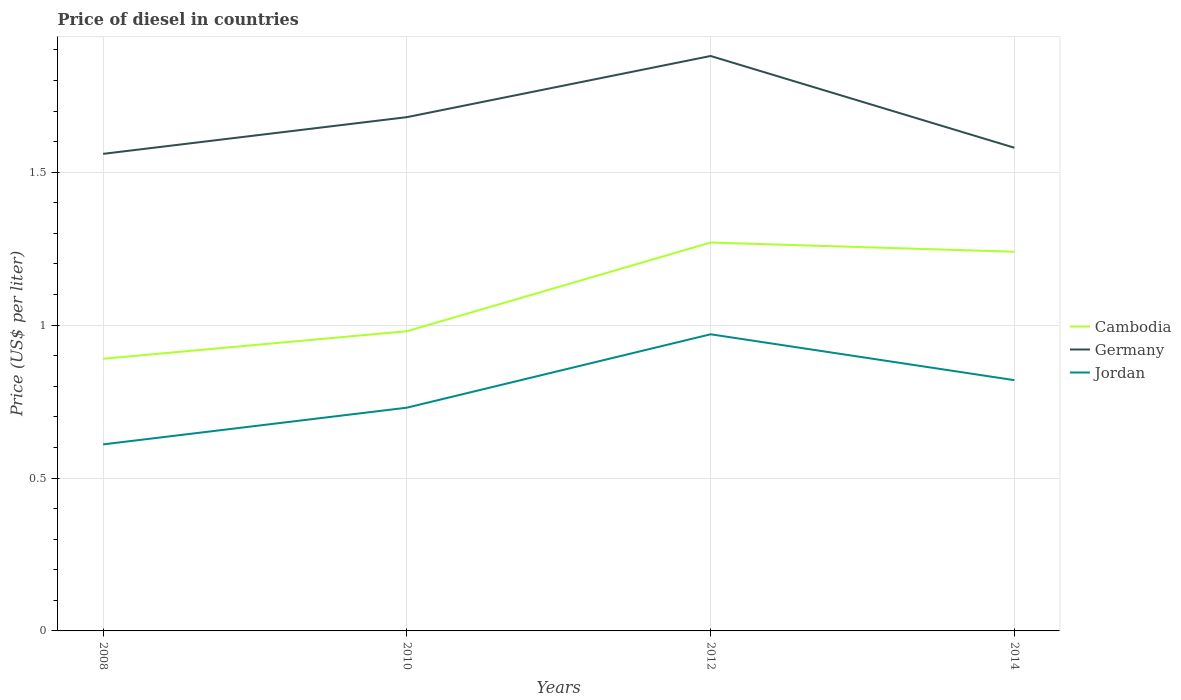Across all years, what is the maximum price of diesel in Germany?
Provide a succinct answer. 1.56. In which year was the price of diesel in Germany maximum?
Make the answer very short. 2008. What is the total price of diesel in Germany in the graph?
Offer a very short reply. -0.02. What is the difference between the highest and the second highest price of diesel in Germany?
Provide a short and direct response. 0.32. What is the difference between two consecutive major ticks on the Y-axis?
Offer a terse response. 0.5. Are the values on the major ticks of Y-axis written in scientific E-notation?
Your answer should be compact. No. What is the title of the graph?
Provide a succinct answer. Price of diesel in countries. What is the label or title of the Y-axis?
Your response must be concise. Price (US$ per liter). What is the Price (US$ per liter) of Cambodia in 2008?
Keep it short and to the point. 0.89. What is the Price (US$ per liter) in Germany in 2008?
Provide a short and direct response. 1.56. What is the Price (US$ per liter) of Jordan in 2008?
Ensure brevity in your answer.  0.61. What is the Price (US$ per liter) in Cambodia in 2010?
Offer a terse response. 0.98. What is the Price (US$ per liter) of Germany in 2010?
Give a very brief answer. 1.68. What is the Price (US$ per liter) of Jordan in 2010?
Your response must be concise. 0.73. What is the Price (US$ per liter) of Cambodia in 2012?
Your answer should be very brief. 1.27. What is the Price (US$ per liter) in Germany in 2012?
Your response must be concise. 1.88. What is the Price (US$ per liter) in Cambodia in 2014?
Make the answer very short. 1.24. What is the Price (US$ per liter) in Germany in 2014?
Provide a succinct answer. 1.58. What is the Price (US$ per liter) of Jordan in 2014?
Offer a terse response. 0.82. Across all years, what is the maximum Price (US$ per liter) of Cambodia?
Provide a succinct answer. 1.27. Across all years, what is the maximum Price (US$ per liter) in Germany?
Keep it short and to the point. 1.88. Across all years, what is the minimum Price (US$ per liter) in Cambodia?
Your response must be concise. 0.89. Across all years, what is the minimum Price (US$ per liter) of Germany?
Give a very brief answer. 1.56. Across all years, what is the minimum Price (US$ per liter) of Jordan?
Make the answer very short. 0.61. What is the total Price (US$ per liter) in Cambodia in the graph?
Keep it short and to the point. 4.38. What is the total Price (US$ per liter) in Jordan in the graph?
Your response must be concise. 3.13. What is the difference between the Price (US$ per liter) of Cambodia in 2008 and that in 2010?
Ensure brevity in your answer.  -0.09. What is the difference between the Price (US$ per liter) of Germany in 2008 and that in 2010?
Offer a very short reply. -0.12. What is the difference between the Price (US$ per liter) in Jordan in 2008 and that in 2010?
Your answer should be very brief. -0.12. What is the difference between the Price (US$ per liter) of Cambodia in 2008 and that in 2012?
Your answer should be compact. -0.38. What is the difference between the Price (US$ per liter) in Germany in 2008 and that in 2012?
Offer a very short reply. -0.32. What is the difference between the Price (US$ per liter) of Jordan in 2008 and that in 2012?
Provide a short and direct response. -0.36. What is the difference between the Price (US$ per liter) of Cambodia in 2008 and that in 2014?
Make the answer very short. -0.35. What is the difference between the Price (US$ per liter) in Germany in 2008 and that in 2014?
Your answer should be compact. -0.02. What is the difference between the Price (US$ per liter) in Jordan in 2008 and that in 2014?
Your answer should be very brief. -0.21. What is the difference between the Price (US$ per liter) in Cambodia in 2010 and that in 2012?
Keep it short and to the point. -0.29. What is the difference between the Price (US$ per liter) in Germany in 2010 and that in 2012?
Offer a terse response. -0.2. What is the difference between the Price (US$ per liter) in Jordan in 2010 and that in 2012?
Make the answer very short. -0.24. What is the difference between the Price (US$ per liter) of Cambodia in 2010 and that in 2014?
Offer a very short reply. -0.26. What is the difference between the Price (US$ per liter) in Germany in 2010 and that in 2014?
Ensure brevity in your answer.  0.1. What is the difference between the Price (US$ per liter) of Jordan in 2010 and that in 2014?
Make the answer very short. -0.09. What is the difference between the Price (US$ per liter) of Cambodia in 2012 and that in 2014?
Provide a succinct answer. 0.03. What is the difference between the Price (US$ per liter) in Jordan in 2012 and that in 2014?
Keep it short and to the point. 0.15. What is the difference between the Price (US$ per liter) of Cambodia in 2008 and the Price (US$ per liter) of Germany in 2010?
Your answer should be compact. -0.79. What is the difference between the Price (US$ per liter) in Cambodia in 2008 and the Price (US$ per liter) in Jordan in 2010?
Offer a very short reply. 0.16. What is the difference between the Price (US$ per liter) of Germany in 2008 and the Price (US$ per liter) of Jordan in 2010?
Provide a succinct answer. 0.83. What is the difference between the Price (US$ per liter) of Cambodia in 2008 and the Price (US$ per liter) of Germany in 2012?
Give a very brief answer. -0.99. What is the difference between the Price (US$ per liter) in Cambodia in 2008 and the Price (US$ per liter) in Jordan in 2012?
Offer a terse response. -0.08. What is the difference between the Price (US$ per liter) in Germany in 2008 and the Price (US$ per liter) in Jordan in 2012?
Provide a short and direct response. 0.59. What is the difference between the Price (US$ per liter) of Cambodia in 2008 and the Price (US$ per liter) of Germany in 2014?
Ensure brevity in your answer.  -0.69. What is the difference between the Price (US$ per liter) in Cambodia in 2008 and the Price (US$ per liter) in Jordan in 2014?
Give a very brief answer. 0.07. What is the difference between the Price (US$ per liter) of Germany in 2008 and the Price (US$ per liter) of Jordan in 2014?
Your response must be concise. 0.74. What is the difference between the Price (US$ per liter) of Cambodia in 2010 and the Price (US$ per liter) of Germany in 2012?
Ensure brevity in your answer.  -0.9. What is the difference between the Price (US$ per liter) in Germany in 2010 and the Price (US$ per liter) in Jordan in 2012?
Your answer should be very brief. 0.71. What is the difference between the Price (US$ per liter) of Cambodia in 2010 and the Price (US$ per liter) of Jordan in 2014?
Offer a terse response. 0.16. What is the difference between the Price (US$ per liter) in Germany in 2010 and the Price (US$ per liter) in Jordan in 2014?
Provide a short and direct response. 0.86. What is the difference between the Price (US$ per liter) in Cambodia in 2012 and the Price (US$ per liter) in Germany in 2014?
Your answer should be compact. -0.31. What is the difference between the Price (US$ per liter) of Cambodia in 2012 and the Price (US$ per liter) of Jordan in 2014?
Your answer should be very brief. 0.45. What is the difference between the Price (US$ per liter) of Germany in 2012 and the Price (US$ per liter) of Jordan in 2014?
Keep it short and to the point. 1.06. What is the average Price (US$ per liter) of Cambodia per year?
Ensure brevity in your answer.  1.09. What is the average Price (US$ per liter) of Germany per year?
Your response must be concise. 1.68. What is the average Price (US$ per liter) of Jordan per year?
Your answer should be compact. 0.78. In the year 2008, what is the difference between the Price (US$ per liter) in Cambodia and Price (US$ per liter) in Germany?
Offer a terse response. -0.67. In the year 2008, what is the difference between the Price (US$ per liter) in Cambodia and Price (US$ per liter) in Jordan?
Keep it short and to the point. 0.28. In the year 2010, what is the difference between the Price (US$ per liter) of Germany and Price (US$ per liter) of Jordan?
Make the answer very short. 0.95. In the year 2012, what is the difference between the Price (US$ per liter) in Cambodia and Price (US$ per liter) in Germany?
Your answer should be compact. -0.61. In the year 2012, what is the difference between the Price (US$ per liter) in Cambodia and Price (US$ per liter) in Jordan?
Provide a succinct answer. 0.3. In the year 2012, what is the difference between the Price (US$ per liter) of Germany and Price (US$ per liter) of Jordan?
Your answer should be compact. 0.91. In the year 2014, what is the difference between the Price (US$ per liter) in Cambodia and Price (US$ per liter) in Germany?
Your answer should be compact. -0.34. In the year 2014, what is the difference between the Price (US$ per liter) in Cambodia and Price (US$ per liter) in Jordan?
Keep it short and to the point. 0.42. In the year 2014, what is the difference between the Price (US$ per liter) of Germany and Price (US$ per liter) of Jordan?
Ensure brevity in your answer.  0.76. What is the ratio of the Price (US$ per liter) in Cambodia in 2008 to that in 2010?
Give a very brief answer. 0.91. What is the ratio of the Price (US$ per liter) of Germany in 2008 to that in 2010?
Offer a terse response. 0.93. What is the ratio of the Price (US$ per liter) of Jordan in 2008 to that in 2010?
Provide a short and direct response. 0.84. What is the ratio of the Price (US$ per liter) in Cambodia in 2008 to that in 2012?
Ensure brevity in your answer.  0.7. What is the ratio of the Price (US$ per liter) of Germany in 2008 to that in 2012?
Give a very brief answer. 0.83. What is the ratio of the Price (US$ per liter) of Jordan in 2008 to that in 2012?
Your answer should be very brief. 0.63. What is the ratio of the Price (US$ per liter) of Cambodia in 2008 to that in 2014?
Make the answer very short. 0.72. What is the ratio of the Price (US$ per liter) of Germany in 2008 to that in 2014?
Keep it short and to the point. 0.99. What is the ratio of the Price (US$ per liter) in Jordan in 2008 to that in 2014?
Provide a short and direct response. 0.74. What is the ratio of the Price (US$ per liter) of Cambodia in 2010 to that in 2012?
Give a very brief answer. 0.77. What is the ratio of the Price (US$ per liter) of Germany in 2010 to that in 2012?
Provide a succinct answer. 0.89. What is the ratio of the Price (US$ per liter) of Jordan in 2010 to that in 2012?
Provide a short and direct response. 0.75. What is the ratio of the Price (US$ per liter) of Cambodia in 2010 to that in 2014?
Give a very brief answer. 0.79. What is the ratio of the Price (US$ per liter) of Germany in 2010 to that in 2014?
Your answer should be very brief. 1.06. What is the ratio of the Price (US$ per liter) of Jordan in 2010 to that in 2014?
Provide a succinct answer. 0.89. What is the ratio of the Price (US$ per liter) in Cambodia in 2012 to that in 2014?
Offer a very short reply. 1.02. What is the ratio of the Price (US$ per liter) in Germany in 2012 to that in 2014?
Keep it short and to the point. 1.19. What is the ratio of the Price (US$ per liter) of Jordan in 2012 to that in 2014?
Provide a short and direct response. 1.18. What is the difference between the highest and the second highest Price (US$ per liter) in Cambodia?
Keep it short and to the point. 0.03. What is the difference between the highest and the second highest Price (US$ per liter) in Germany?
Offer a terse response. 0.2. What is the difference between the highest and the lowest Price (US$ per liter) in Cambodia?
Offer a terse response. 0.38. What is the difference between the highest and the lowest Price (US$ per liter) in Germany?
Offer a terse response. 0.32. What is the difference between the highest and the lowest Price (US$ per liter) of Jordan?
Make the answer very short. 0.36. 